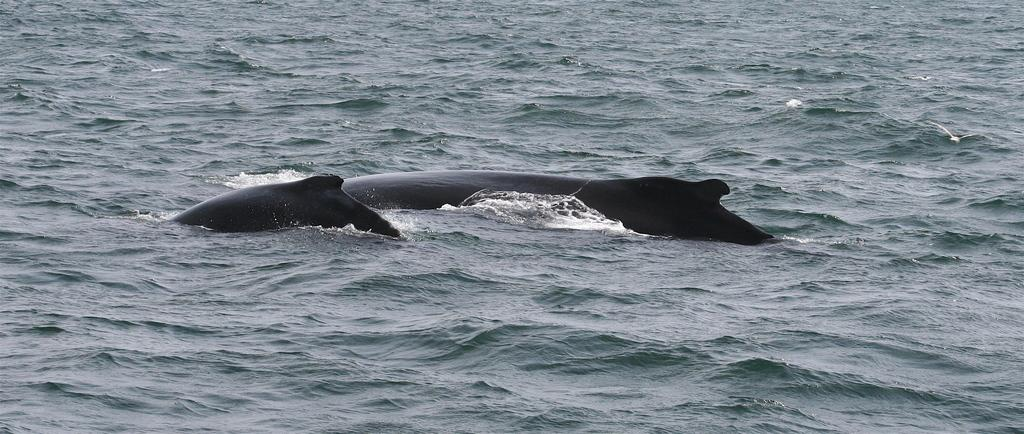What is the main subject in the center of the image? There is a whale in the center of the image. What type of water body is visible at the bottom of the image? There is a river at the bottom of the image. What type of list can be seen hanging on the wall in the image? There is no list or wall present in the image; it features a whale and a river. How many babies are visible in the image? There are no babies present in the image; it features a whale and a river. 